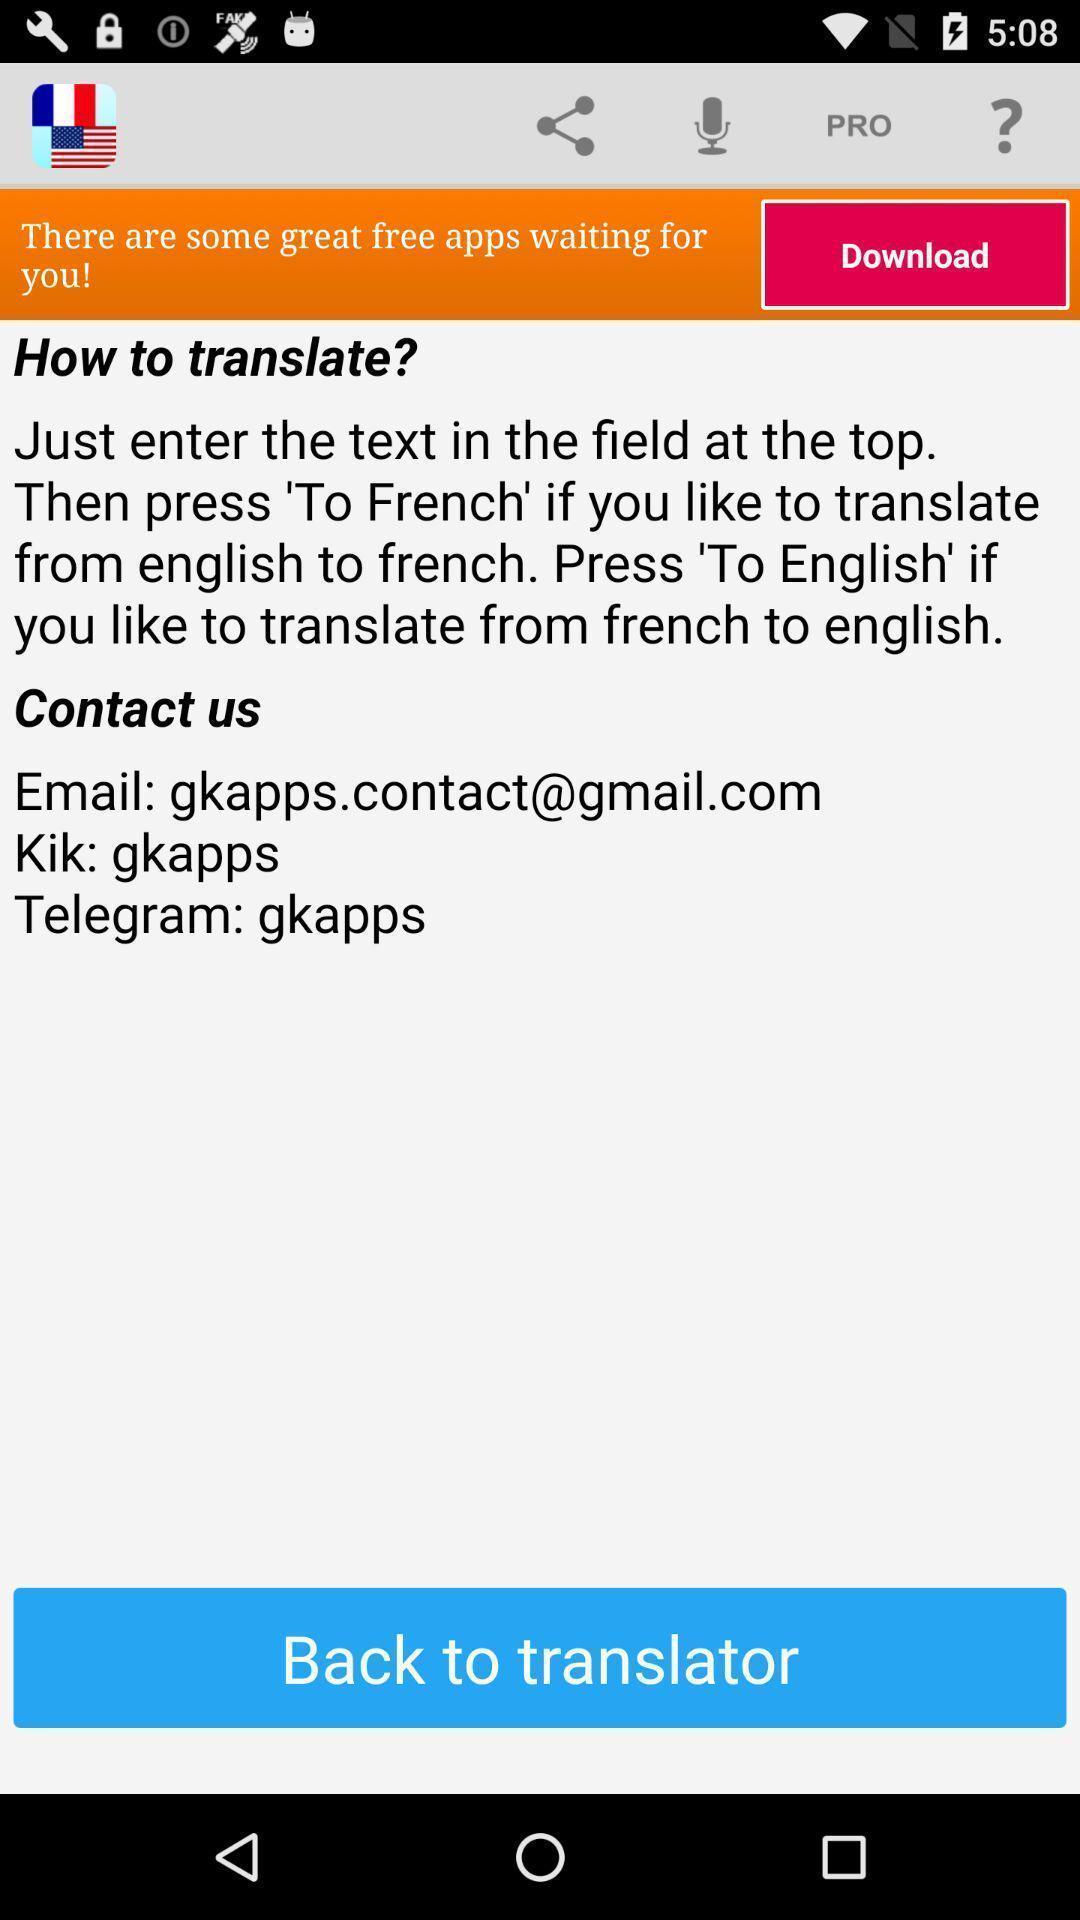What can you discern from this picture? Translation app guide lines with contact details and options. 